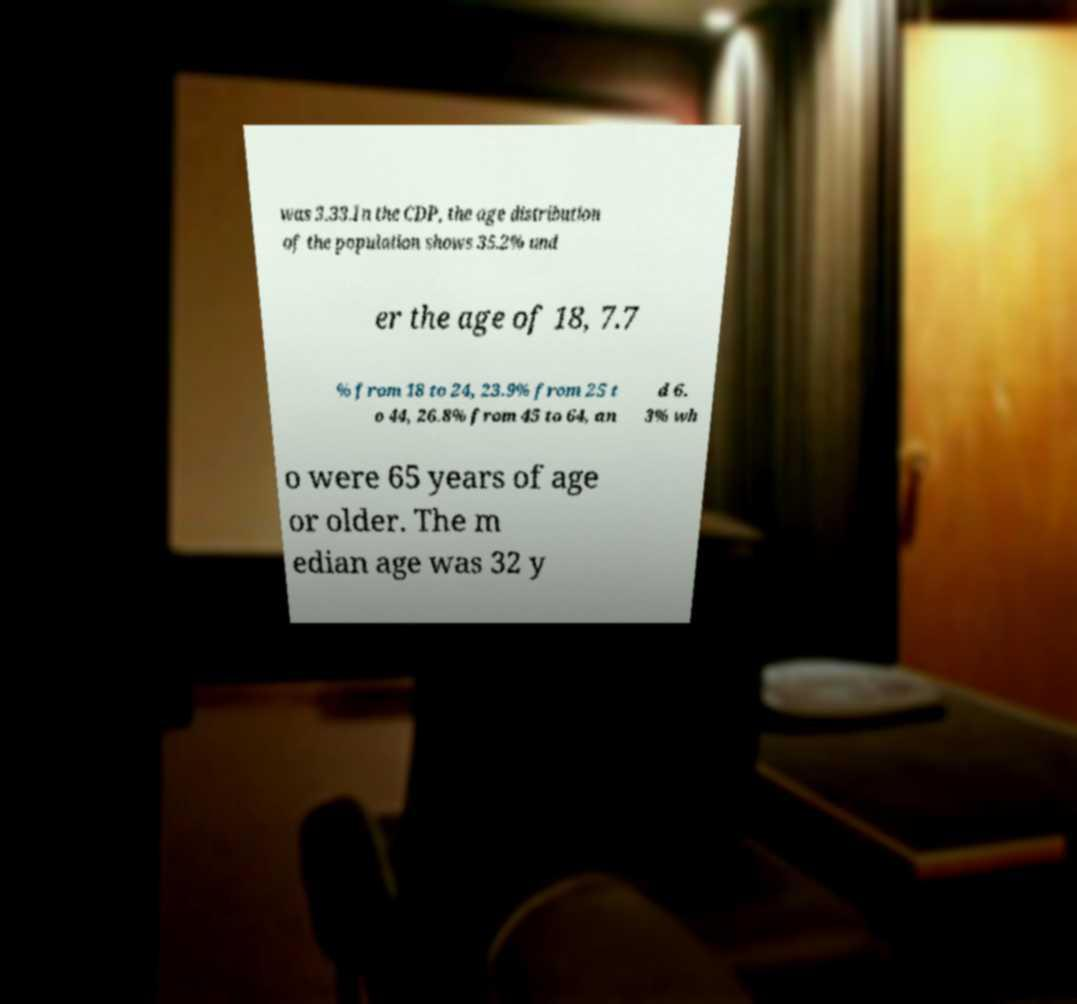Can you read and provide the text displayed in the image?This photo seems to have some interesting text. Can you extract and type it out for me? was 3.33.In the CDP, the age distribution of the population shows 35.2% und er the age of 18, 7.7 % from 18 to 24, 23.9% from 25 t o 44, 26.8% from 45 to 64, an d 6. 3% wh o were 65 years of age or older. The m edian age was 32 y 